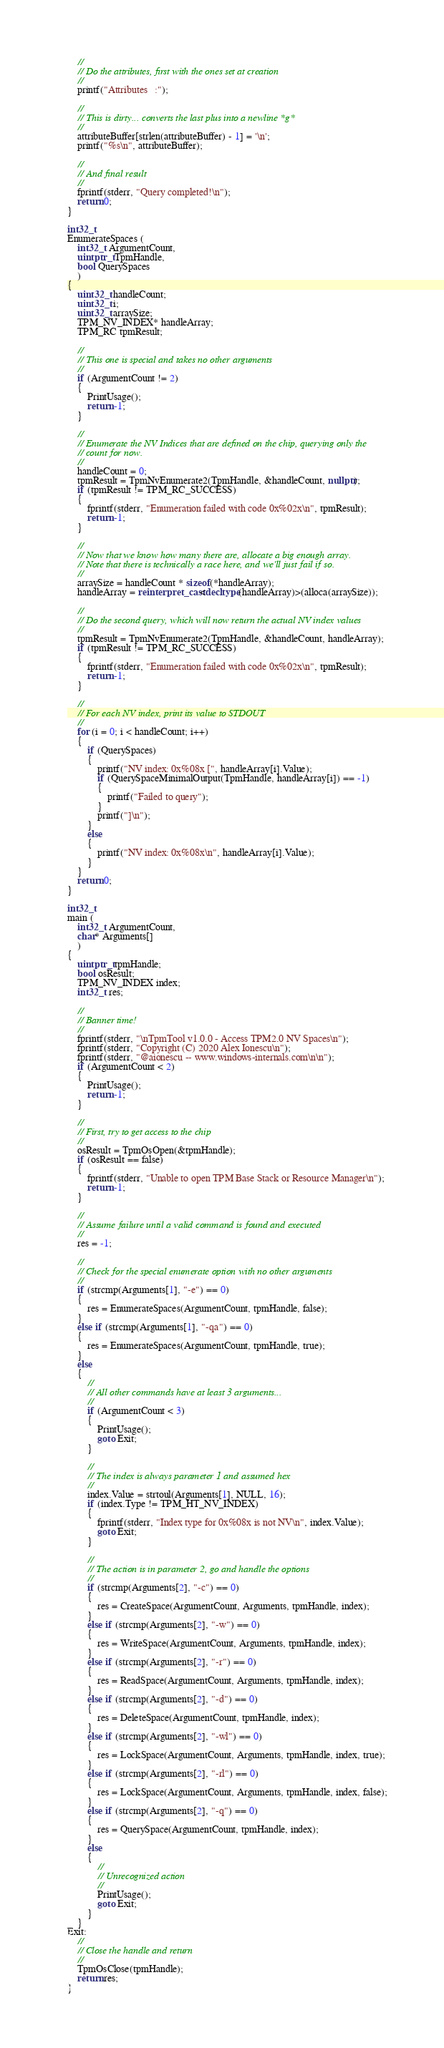<code> <loc_0><loc_0><loc_500><loc_500><_C++_>
    //
    // Do the attributes, first with the ones set at creation
    //
    printf("Attributes   :");

    //
    // This is dirty... converts the last plus into a newline *g*
    //
    attributeBuffer[strlen(attributeBuffer) - 1] = '\n';
    printf("%s\n", attributeBuffer);

    //
    // And final result
    //
    fprintf(stderr, "Query completed!\n");
    return 0;
}

int32_t
EnumerateSpaces (
    int32_t ArgumentCount,
    uintptr_t TpmHandle,
    bool QuerySpaces
    )
{
    uint32_t handleCount;
    uint32_t i;
    uint32_t arraySize;
    TPM_NV_INDEX* handleArray;
    TPM_RC tpmResult;

    //
    // This one is special and takes no other arguments
    //
    if (ArgumentCount != 2)
    {
        PrintUsage();
        return -1;
    }

    //
    // Enumerate the NV Indices that are defined on the chip, querying only the
    // count for now.
    //
    handleCount = 0;
    tpmResult = TpmNvEnumerate2(TpmHandle, &handleCount, nullptr);
    if (tpmResult != TPM_RC_SUCCESS)
    {
        fprintf(stderr, "Enumeration failed with code 0x%02x\n", tpmResult);
        return -1;
    }

    //
    // Now that we know how many there are, allocate a big enough array.
    // Note that there is technically a race here, and we'll just fail if so.
    //
    arraySize = handleCount * sizeof(*handleArray);
    handleArray = reinterpret_cast<decltype(handleArray)>(alloca(arraySize));

    //
    // Do the second query, which will now return the actual NV index values
    //
    tpmResult = TpmNvEnumerate2(TpmHandle, &handleCount, handleArray);
    if (tpmResult != TPM_RC_SUCCESS)
    {
        fprintf(stderr, "Enumeration failed with code 0x%02x\n", tpmResult);
        return -1;
    }

    //
    // For each NV index, print its value to STDOUT
    //
    for (i = 0; i < handleCount; i++)
    {
        if (QuerySpaces)
        {
            printf("NV index: 0x%08x [", handleArray[i].Value);
            if (QuerySpaceMinimalOutput(TpmHandle, handleArray[i]) == -1)
            {
                printf("Failed to query");
            }
            printf("]\n");
        }
        else
        {
            printf("NV index: 0x%08x\n", handleArray[i].Value);
        }
    }
    return 0;
}

int32_t
main (
    int32_t ArgumentCount,
    char* Arguments[]
    )
{
    uintptr_t tpmHandle;
    bool osResult;
    TPM_NV_INDEX index;
    int32_t res;

    //
    // Banner time!
    //
    fprintf(stderr, "\nTpmTool v1.0.0 - Access TPM2.0 NV Spaces\n");
    fprintf(stderr, "Copyright (C) 2020 Alex Ionescu\n");
    fprintf(stderr, "@aionescu -- www.windows-internals.com\n\n");
    if (ArgumentCount < 2)
    {
        PrintUsage();
        return -1;
    }

    //
    // First, try to get access to the chip
    //
    osResult = TpmOsOpen(&tpmHandle);
    if (osResult == false)
    {
        fprintf(stderr, "Unable to open TPM Base Stack or Resource Manager\n");
        return -1;
    }

    //
    // Assume failure until a valid command is found and executed
    //
    res = -1;

    //
    // Check for the special enumerate option with no other arguments
    //
    if (strcmp(Arguments[1], "-e") == 0)
    {
        res = EnumerateSpaces(ArgumentCount, tpmHandle, false);
    }
    else if (strcmp(Arguments[1], "-qa") == 0)
    {
        res = EnumerateSpaces(ArgumentCount, tpmHandle, true);
    }
    else
    {
        //
        // All other commands have at least 3 arguments...
        //
        if (ArgumentCount < 3)
        {
            PrintUsage();
            goto Exit;
        }

        //
        // The index is always parameter 1 and assumed hex
        //
        index.Value = strtoul(Arguments[1], NULL, 16);
        if (index.Type != TPM_HT_NV_INDEX)
        {
            fprintf(stderr, "Index type for 0x%08x is not NV\n", index.Value);
            goto Exit;
        }

        //
        // The action is in parameter 2, go and handle the options
        //
        if (strcmp(Arguments[2], "-c") == 0)
        {
            res = CreateSpace(ArgumentCount, Arguments, tpmHandle, index);
        }
        else if (strcmp(Arguments[2], "-w") == 0)
        {
            res = WriteSpace(ArgumentCount, Arguments, tpmHandle, index);
        }
        else if (strcmp(Arguments[2], "-r") == 0)
        {
            res = ReadSpace(ArgumentCount, Arguments, tpmHandle, index);
        }
        else if (strcmp(Arguments[2], "-d") == 0)
        {
            res = DeleteSpace(ArgumentCount, tpmHandle, index);
        }
        else if (strcmp(Arguments[2], "-wl") == 0)
        {
            res = LockSpace(ArgumentCount, Arguments, tpmHandle, index, true);
        }
        else if (strcmp(Arguments[2], "-rl") == 0)
        {
            res = LockSpace(ArgumentCount, Arguments, tpmHandle, index, false);
        }
        else if (strcmp(Arguments[2], "-q") == 0)
        {
            res = QuerySpace(ArgumentCount, tpmHandle, index);
        }
        else
        {
            //
            // Unrecognized action
            //
            PrintUsage();
            goto Exit;
        }
    }
Exit:
    //
    // Close the handle and return
    //
    TpmOsClose(tpmHandle);
    return res;
}
</code> 